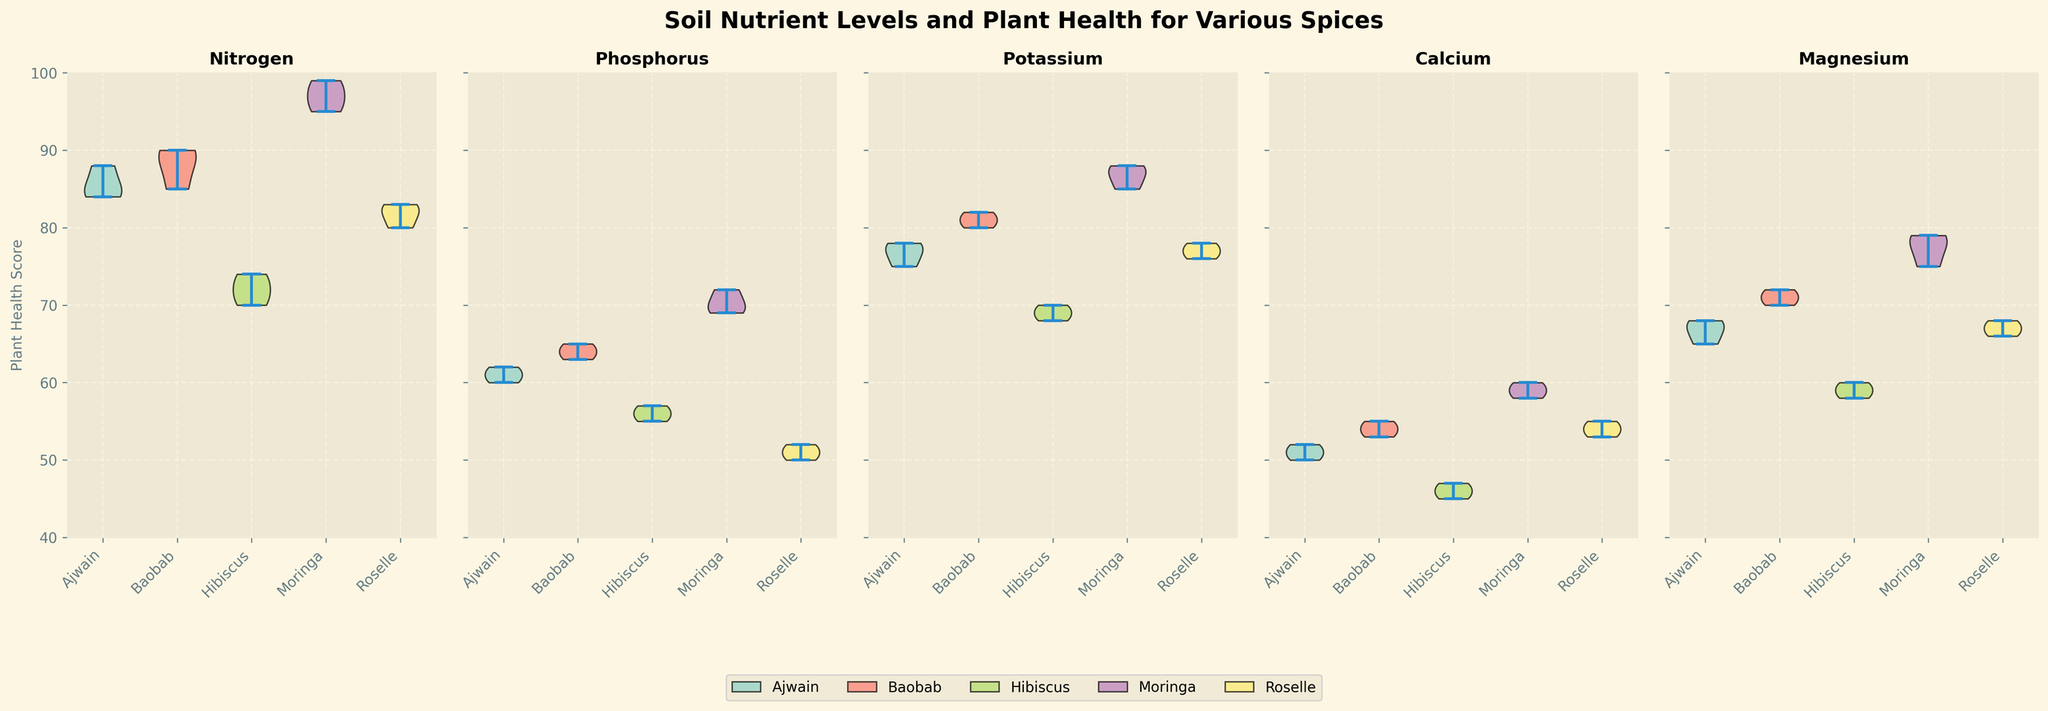What is the title of the figure? The title is usually at the top of the figure and describes the overall content. In this case, the title is stated clearly.
Answer: Soil Nutrient Levels and Plant Health for Various Spices Which spice shows the highest plant health score under Nitrogen? Look at the Nitrogen subplot and identify the spice with the peak value.
Answer: Moringa How does the median plant health score of Ajwain compare between Nitrogen and Phosphorus? Identify the median of Ajwain in both Nitrogen and Phosphorus subplots. The median is usually at the thickest part of the violin plot.
Answer: Higher in Nitrogen Which spice has the most consistent plant health score under Magnesium (least spread)? Check the Magnesium subplot and identify the spice with the narrowest spread in the violin plot.
Answer: Roselle Under which nutrient do all spices have relatively similar health scores? Identify the nutrient subplot where the spreads (range) of all spices are close together.
Answer: Phosphorus What is the range of plant health scores for Hibiscus under Calcium? Identify the highest and lowest points of the Hibiscus violin plot in the Calcium subplot.
Answer: 45 to 47 Which nutrient shows the largest variation in plant health scores for Roselle? Compare the spreads in Roselle's violin plots across all nutrients and identify the widest one.
Answer: Magnesium How does Baobab's plant health score range under Potassium compare to Ajwain's under the same nutrient? Compare the width of the violin plots for Baobab and Ajwain under Potassium.
Answer: Baobab has a wider range Rank the spices by their maximum plant health score under Nitrogen. Compare the peaks of each spice's violin plot under Nitrogen and rank them.
Answer: Moringa > Baobab > Ajwain > Roselle > Hibiscus Which nutrient leads to the lowest plant health score for any spice? Look for the lowest single point in all subplots. Identify the nutrient and the corresponding spice.
Answer: Phosphorus for Hibiscus 